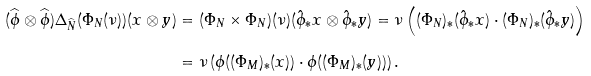<formula> <loc_0><loc_0><loc_500><loc_500>( \widehat { \phi } \otimes \widehat { \phi } ) \Delta _ { \widehat { N } } ( \Phi _ { N } ( \nu ) ) ( x \otimes y ) & = ( \Phi _ { N } \times \Phi _ { N } ) ( \nu ) ( \hat { \phi } _ { * } x \otimes \hat { \phi } _ { * } y ) = \nu \left ( ( \Phi _ { N } ) _ { * } ( \hat { \phi } _ { * } x ) \cdot ( \Phi _ { N } ) _ { * } ( \hat { \phi } _ { * } y ) \right ) \\ & = \nu \left ( \phi ( ( \Phi _ { M } ) _ { * } ( x ) ) \cdot \phi ( ( \Phi _ { M } ) _ { * } ( y ) ) \right ) .</formula> 